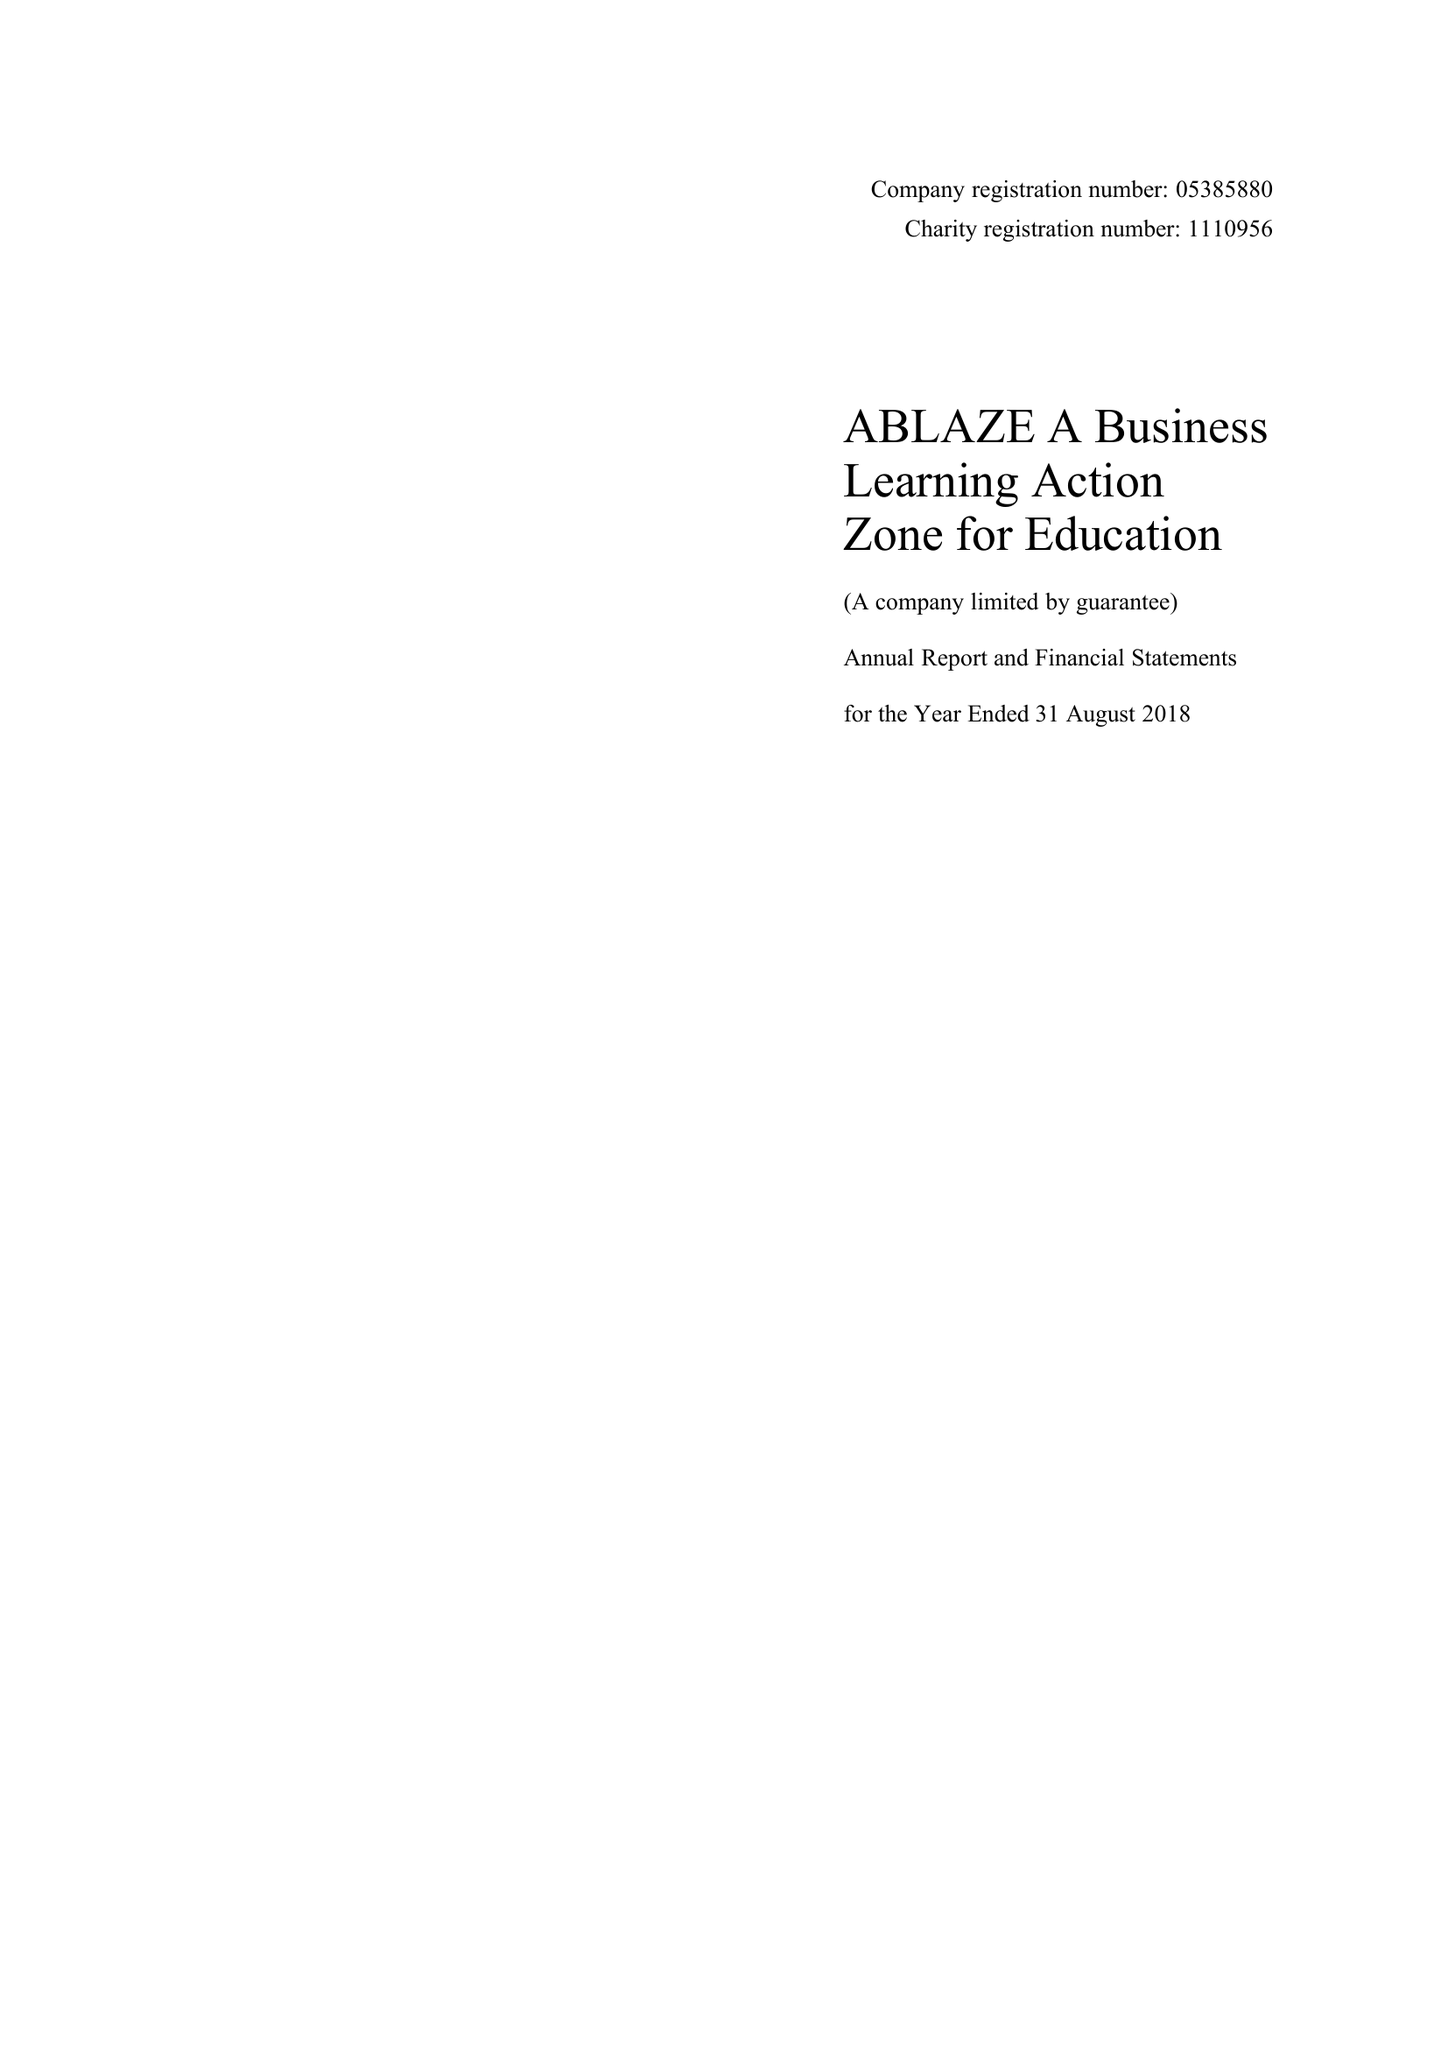What is the value for the spending_annually_in_british_pounds?
Answer the question using a single word or phrase. 133432.00 